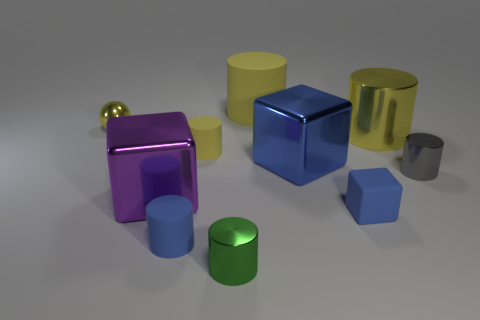There is another tiny metallic thing that is the same shape as the green object; what color is it?
Offer a terse response. Gray. What number of tiny objects are the same color as the metallic ball?
Offer a very short reply. 1. Is the metal ball the same color as the tiny matte cube?
Your answer should be compact. No. How many things are either blue things that are on the left side of the small blue cube or tiny blocks?
Offer a very short reply. 3. The thing behind the metallic thing left of the large metal object in front of the small gray metal cylinder is what color?
Your answer should be compact. Yellow. There is a ball that is the same material as the tiny green object; what is its color?
Provide a succinct answer. Yellow. What number of red blocks are the same material as the large purple block?
Your answer should be very brief. 0. Is the size of the yellow matte cylinder behind the sphere the same as the blue metallic thing?
Your response must be concise. Yes. What color is the rubber cube that is the same size as the metallic ball?
Offer a very short reply. Blue. What number of small yellow metal things are on the right side of the small ball?
Provide a short and direct response. 0. 